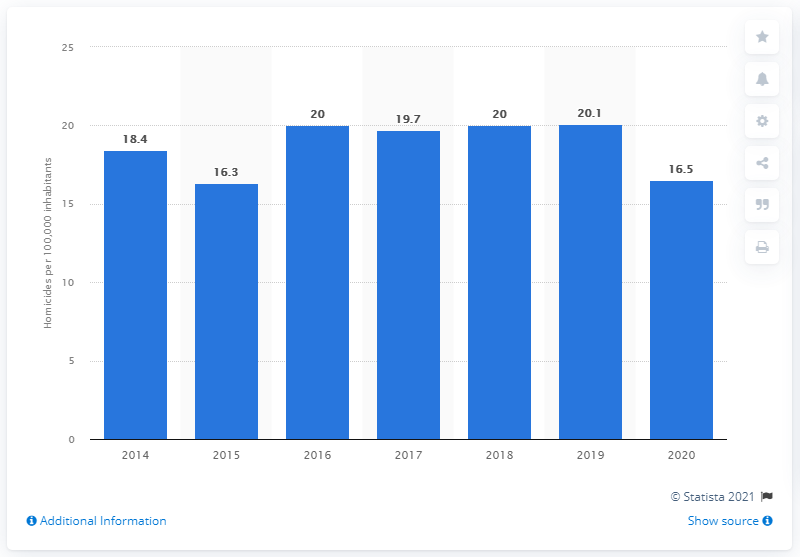Identify some key points in this picture. In 2019, Puerto Rico's highest homicide rate was 20.1 per 100,000 residents. According to data from 2020, the homicide rate in Puerto Rico was 16.5 per 100,000 inhabitants. 